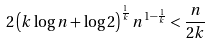Convert formula to latex. <formula><loc_0><loc_0><loc_500><loc_500>2 \left ( k \log n + \log 2 \right ) ^ { \frac { 1 } { k } } n ^ { 1 - \frac { 1 } { k } } < \frac { n } { 2 k }</formula> 